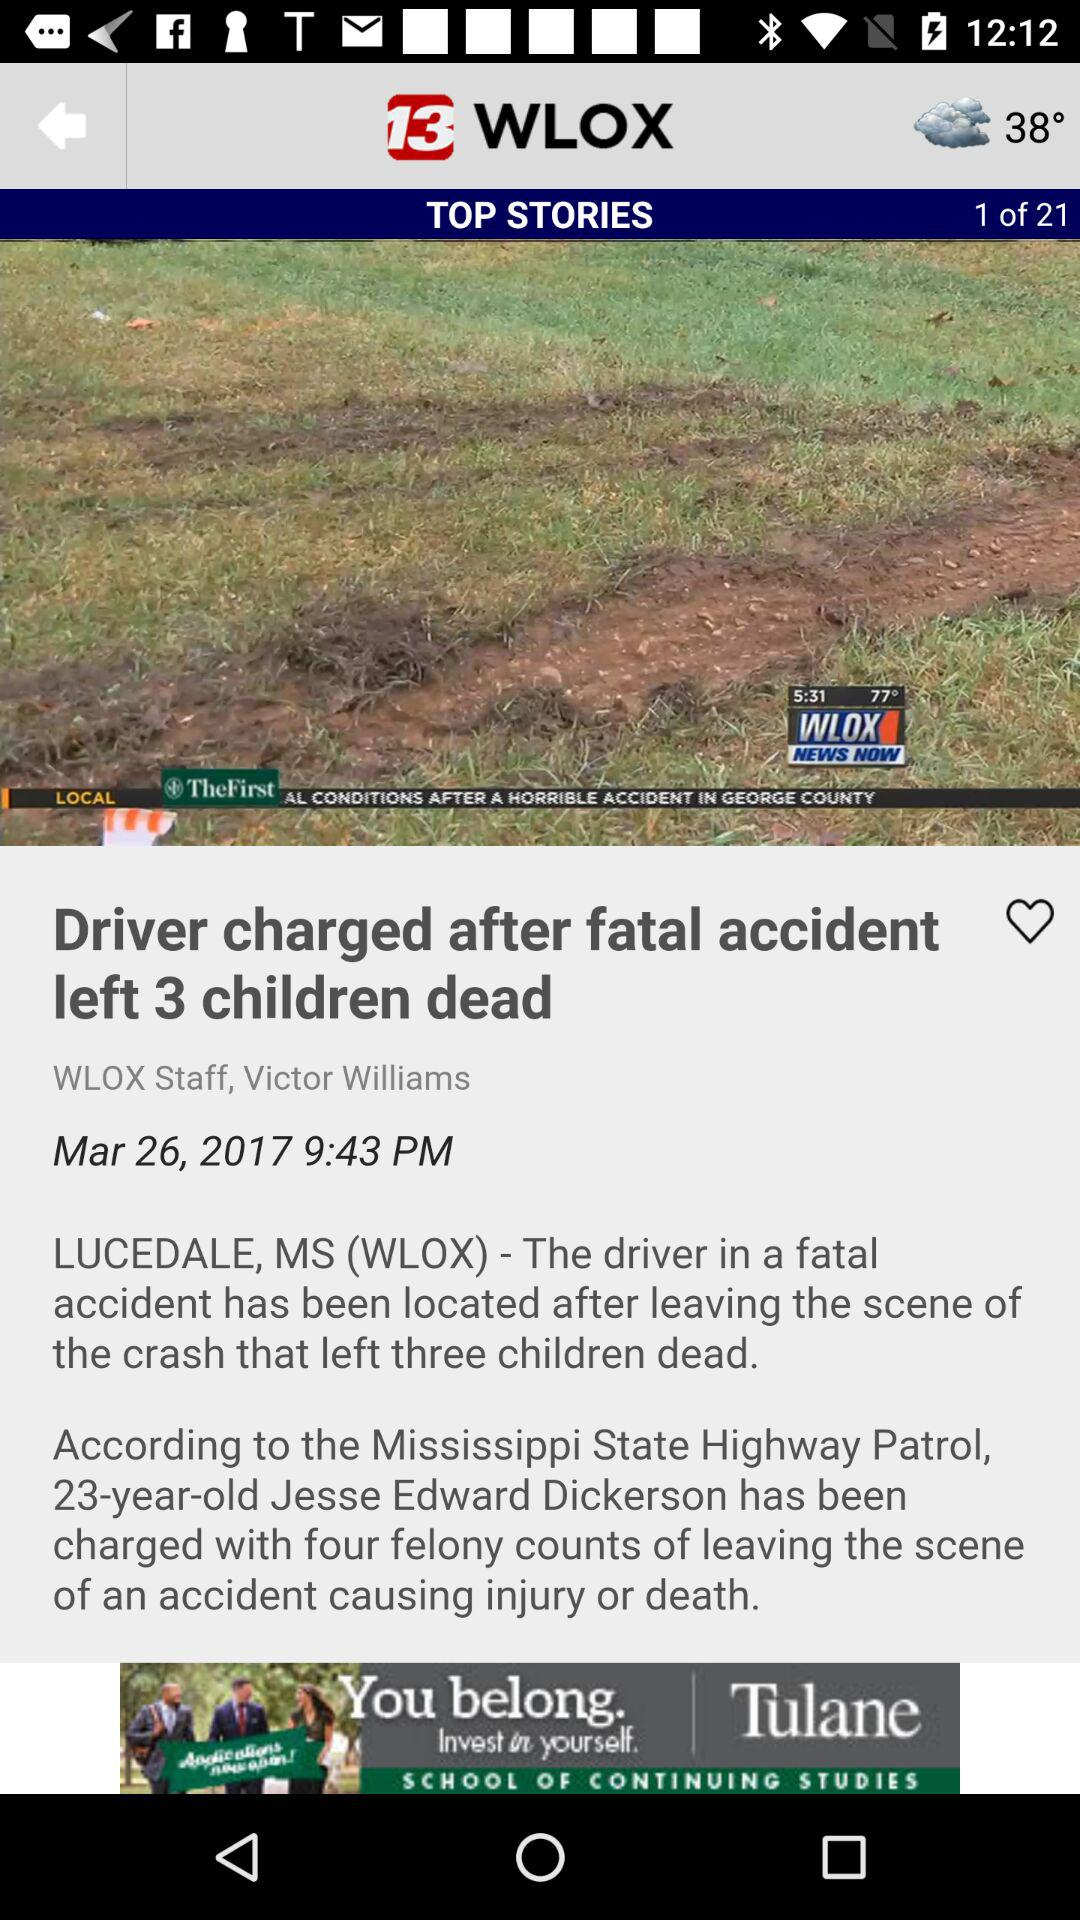How many comments were left on this article?
When the provided information is insufficient, respond with <no answer>. <no answer> 